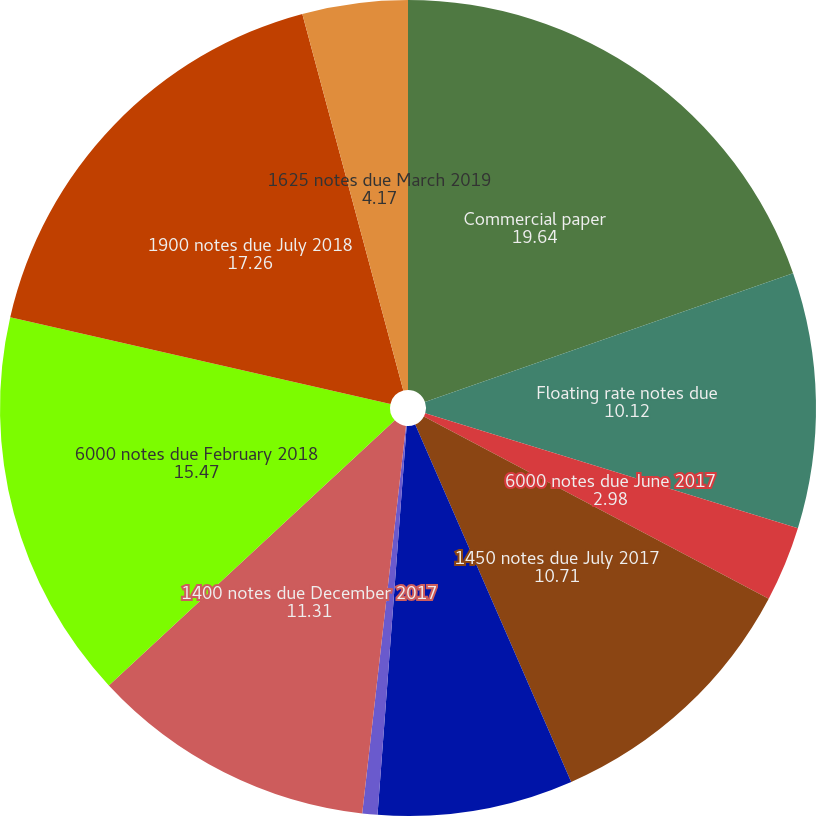<chart> <loc_0><loc_0><loc_500><loc_500><pie_chart><fcel>Commercial paper<fcel>Floating rate notes due<fcel>6000 notes due June 2017<fcel>1450 notes due July 2017<fcel>1400 notes due October 2017<fcel>6000 notes due November 2017<fcel>1400 notes due December 2017<fcel>6000 notes due February 2018<fcel>1900 notes due July 2018<fcel>1625 notes due March 2019<nl><fcel>19.64%<fcel>10.12%<fcel>2.98%<fcel>10.71%<fcel>7.74%<fcel>0.6%<fcel>11.31%<fcel>15.47%<fcel>17.26%<fcel>4.17%<nl></chart> 